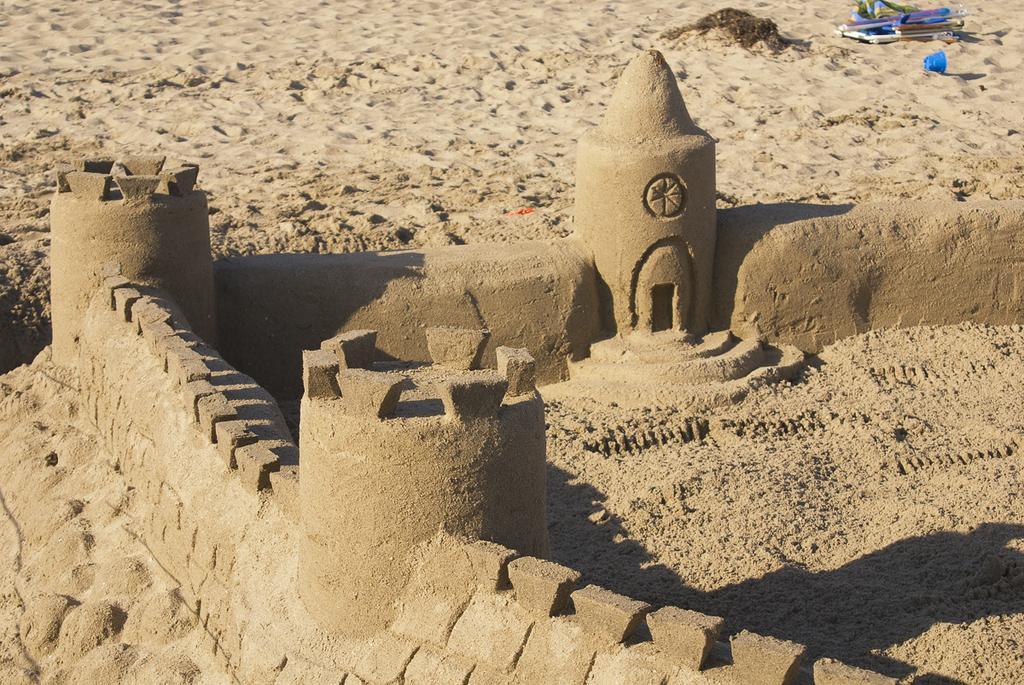In one or two sentences, can you explain what this image depicts? In this image I can see the sand castle. To the side I can see few objects on the sand. 